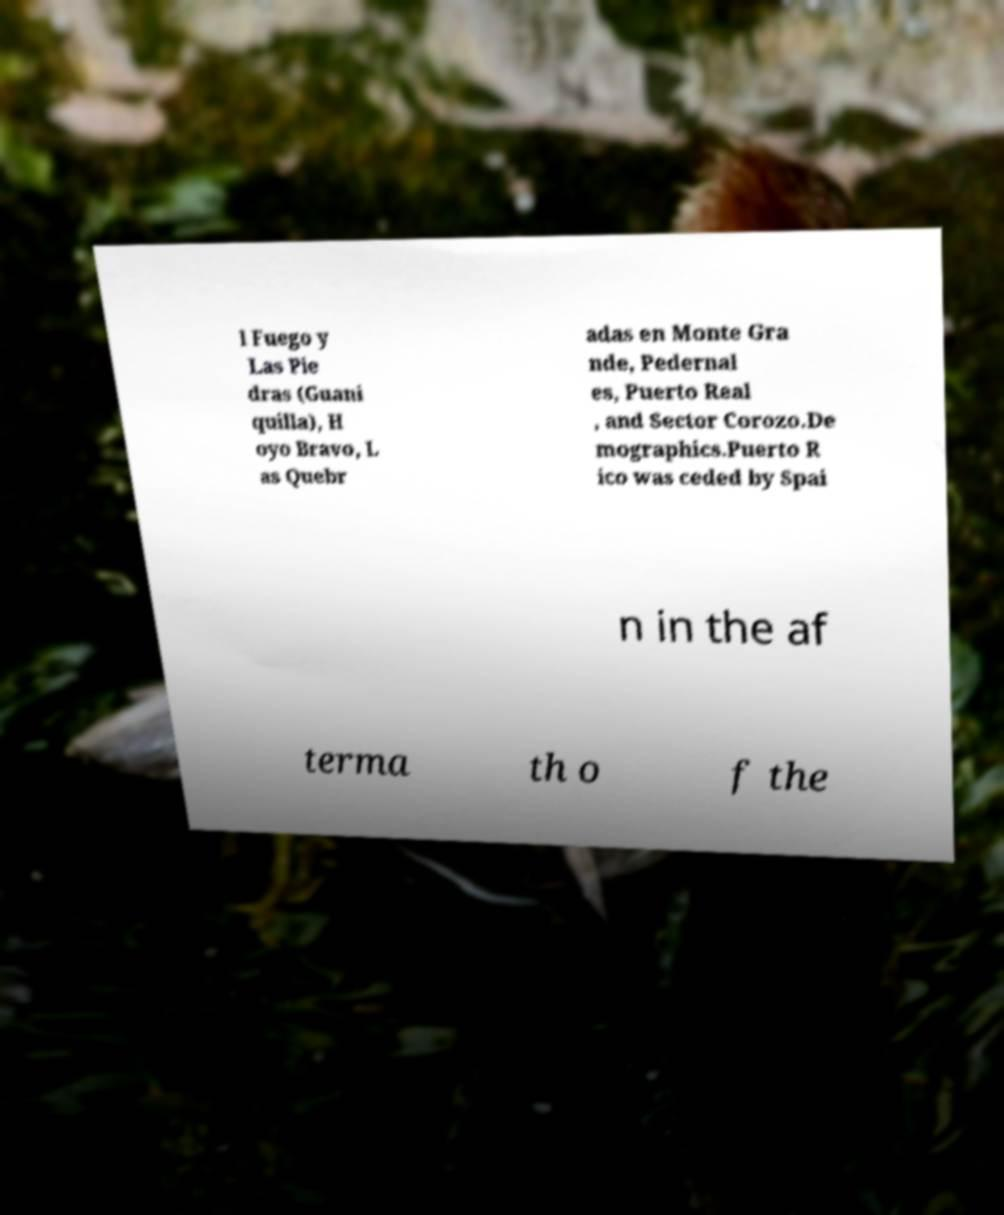Can you accurately transcribe the text from the provided image for me? l Fuego y Las Pie dras (Guani quilla), H oyo Bravo, L as Quebr adas en Monte Gra nde, Pedernal es, Puerto Real , and Sector Corozo.De mographics.Puerto R ico was ceded by Spai n in the af terma th o f the 